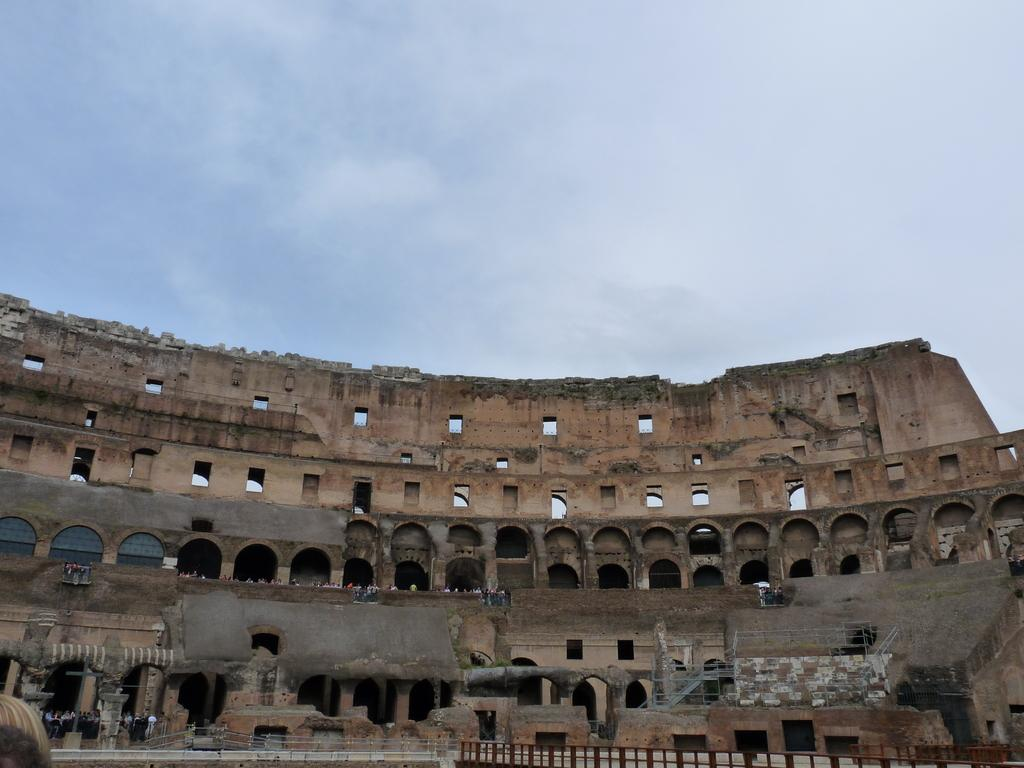What type of building is in the image? There is a stone building in the image. What architectural feature can be seen in the building? The building has an arch construction. What is the condition of the sky in the image? The sky is cloudy and pale blue. What can be seen in the image besides the building? There is a fence and people visible in the image. What type of butter is being used to grease the wheel in the image? There is no butter or wheel present in the image. 